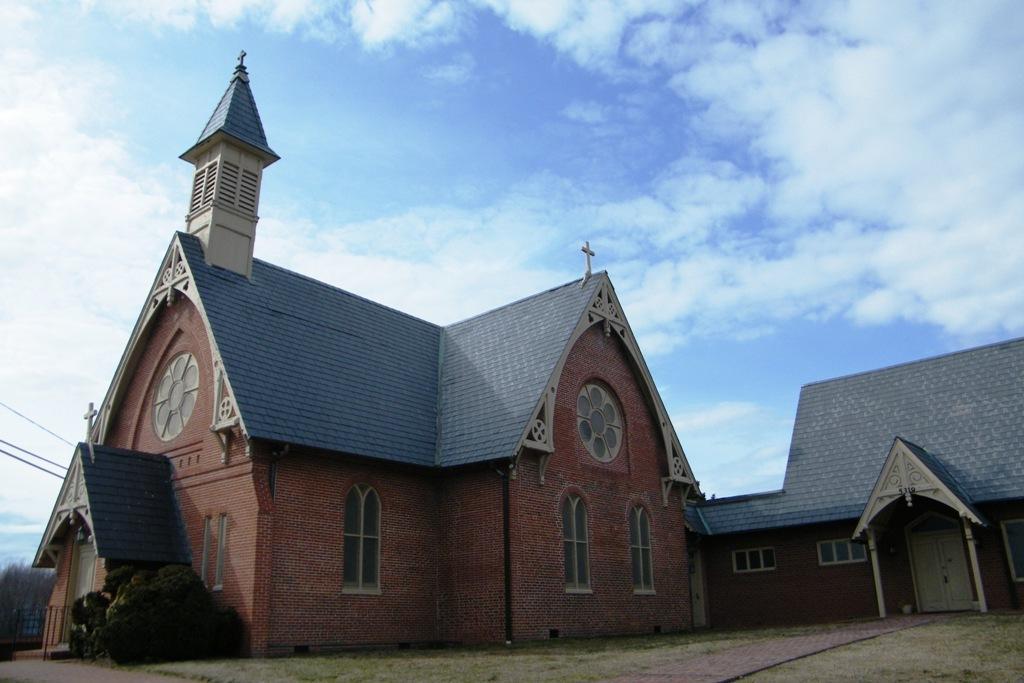Please provide a concise description of this image. In this image we can see a castle, plants, wires and the sky with clouds in the background. 